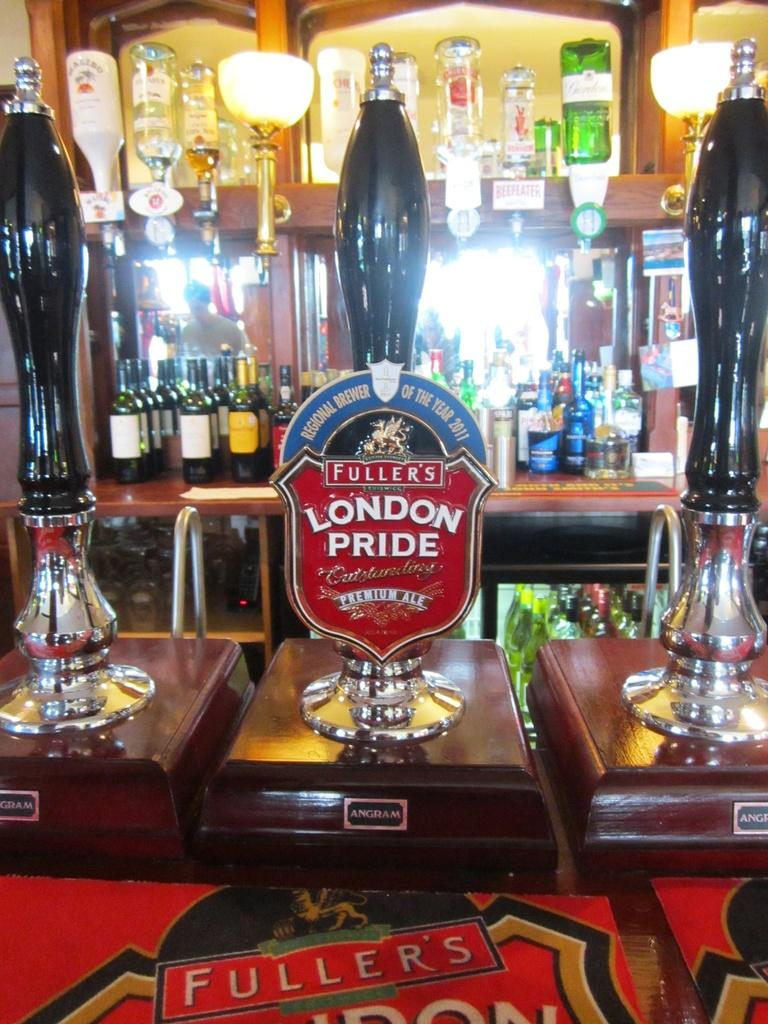<image>
Summarize the visual content of the image. A beer tap trophy for Brewer of the Yea 2014 for Fuller's London Pride premium ale on a bar next to other taps. 